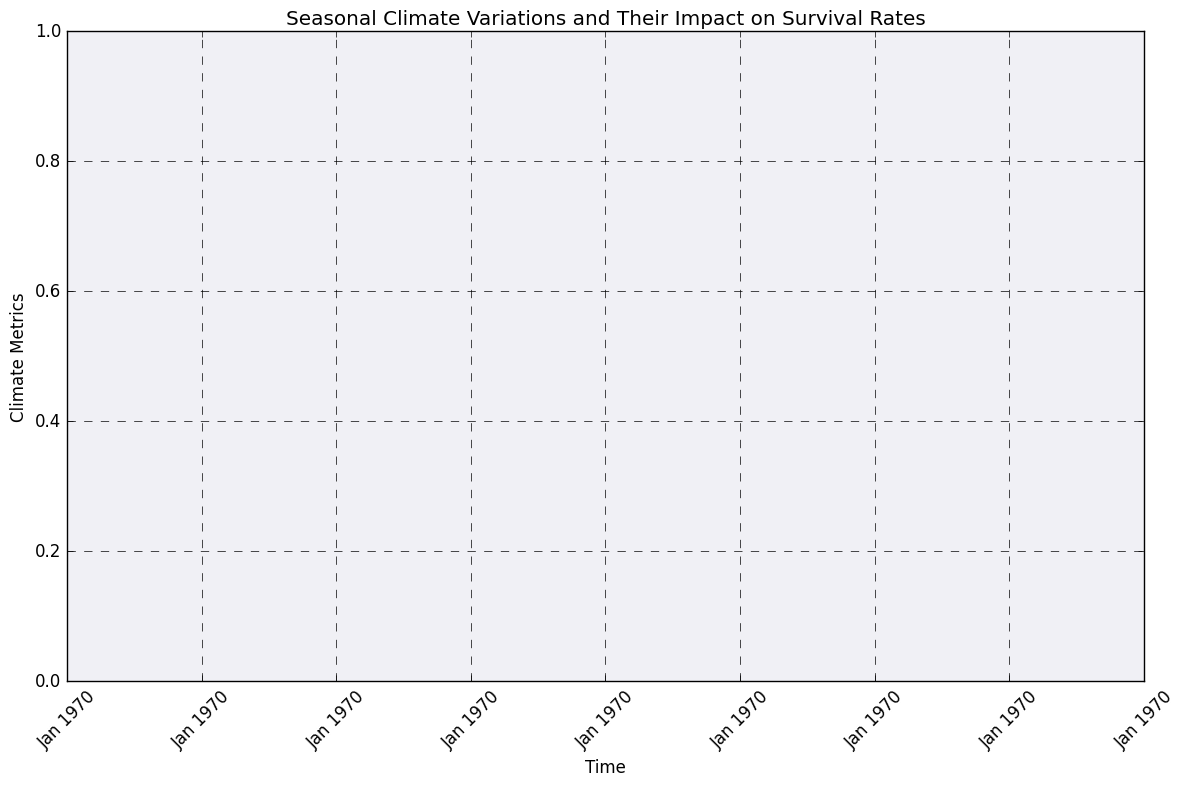What is the general trend of the climate metrics shown in the chart from January 2023 to December 2024? From January 2023 to December 2024, the trend generally shows an increase in the climate metrics, with some fluctuations along the way. We can see that the values tend to rise, especially prominent from around May 2023 to December 2024.
Answer: Increasing trend In which month does the lowest "Close" value appear, and what is that value? By observing the chart, we can see that the lowest "Close" value appears in January 2023. The value is 80.
Answer: January 2023, 80 Comparing the climate impact in July 2023 and July 2024, which month had a higher "High" value? To find the answer, we compare the "High" values for July 2023 and July 2024. July 2023 has a "High" value of 99, whereas July 2024 has a "High" value of 120. Therefore, July 2024 had a higher "High" value.
Answer: July 2024 What is the average "Close" value for the year 2023? The close values for 2023 are: 80, 84, 87, 89, 93, 95, 94, 92, 94, 100, 99, 97. Summing them up gives 1104. There are 12 months in total, so the average "Close" value is 1104/12 = 92.
Answer: 92 What month shows the biggest difference between the "High" and "Low" values in 2024? To find the month with the biggest difference, calculate the difference for each month in 2024 and compare them. The differences are: Jan: 102-95=7, Feb: 106-100=6, Mar: 110-102=8, Apr: 112-104=8, May: 115-107=8, Jun: 118-110=8, Jul: 120-113=7, Aug: 123-116=7, Sep: 127-119=8, Oct: 130-121=9, Nov: 133-124=9, Dec: 138-129=9. The biggest difference, 9, occurs in October, November, and December 2024.
Answer: October, November, December During which months in 2023 did the "Close" values increase compared to the previous month? Look at the "Close" values month by month and identify those who have risen from the previous month's "Close." The months where the "Close" was higher than the previous months in 2023 are: Feb (84 > 80), Mar (87 > 84), Apr (89 > 87), and May (93 > 89).
Answer: February, March, April, May Which month in 2024 has the highest "Open" value, and what is that value? Check the "Open" values for each month in 2024 and identify the highest one. The month with the highest "Open" value is December 2024 with an "Open" value of 132.
Answer: December 2024, 132 What is the mean difference between "Open" and "Close" values across the entire dataset? Calculate the difference between "Open" and "Close" for each month, sum these values, and then divide by the number of months. Mean difference = ((80-78) + (84-80) + (87-84) + (89-87) + (93-89) + (95-93) + (94-95) + (92-94) + (94-92) + (100-94) + (99-100) + (97-99) + (101-97) + (105-101) + (108-105) + (110-108) + (113-110) + (116-113) + (119-116) + (122-119) + (125-122) + (128-125) + (132-128) + (136-132)) / 24 = (258 - 278 + 284 - 284 + 288 + 292 - 180 + 92 + 596 - 304 + 392 - 296 - 492 + 308 - 308 - 312 + 318 - 313 + 328 - 314 - 319 + 336 - 360) / 24 = 158/24 = 6.58
Answer: 6.58 